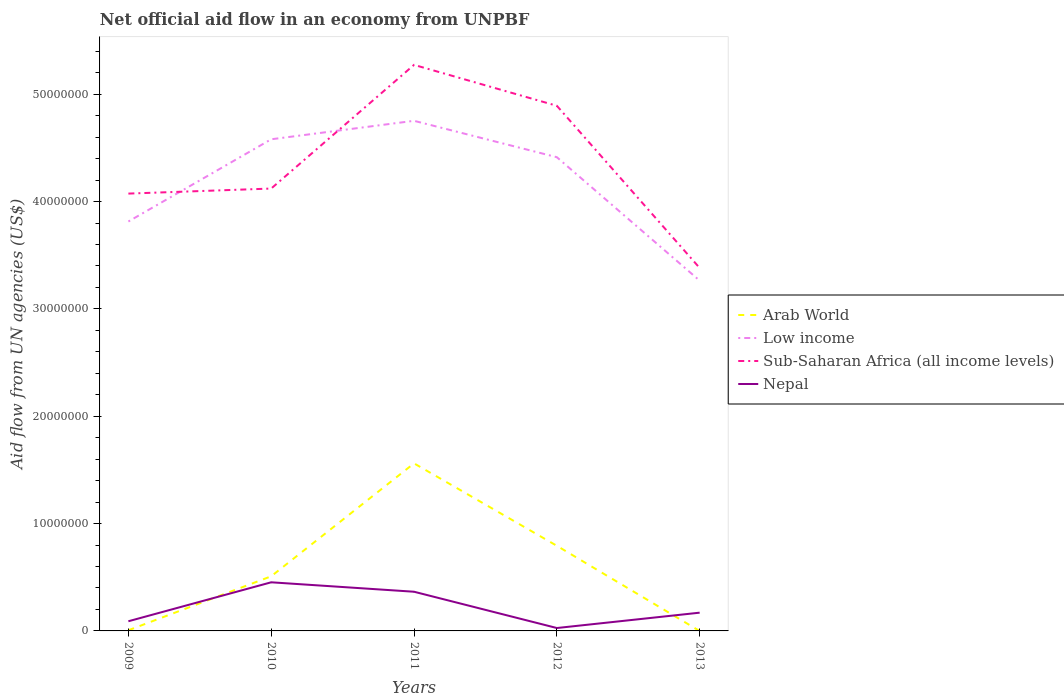How many different coloured lines are there?
Your answer should be very brief. 4. Does the line corresponding to Nepal intersect with the line corresponding to Arab World?
Give a very brief answer. Yes. Is the number of lines equal to the number of legend labels?
Give a very brief answer. No. Across all years, what is the maximum net official aid flow in Sub-Saharan Africa (all income levels)?
Offer a very short reply. 3.38e+07. What is the total net official aid flow in Nepal in the graph?
Provide a succinct answer. 3.38e+06. What is the difference between the highest and the second highest net official aid flow in Nepal?
Provide a succinct answer. 4.26e+06. Is the net official aid flow in Nepal strictly greater than the net official aid flow in Arab World over the years?
Keep it short and to the point. No. How many lines are there?
Provide a succinct answer. 4. What is the difference between two consecutive major ticks on the Y-axis?
Your answer should be compact. 1.00e+07. Does the graph contain any zero values?
Provide a short and direct response. Yes. Does the graph contain grids?
Offer a very short reply. No. Where does the legend appear in the graph?
Provide a short and direct response. Center right. How many legend labels are there?
Ensure brevity in your answer.  4. How are the legend labels stacked?
Offer a terse response. Vertical. What is the title of the graph?
Provide a succinct answer. Net official aid flow in an economy from UNPBF. Does "Malta" appear as one of the legend labels in the graph?
Your answer should be very brief. No. What is the label or title of the X-axis?
Offer a terse response. Years. What is the label or title of the Y-axis?
Your answer should be compact. Aid flow from UN agencies (US$). What is the Aid flow from UN agencies (US$) in Low income in 2009?
Provide a short and direct response. 3.81e+07. What is the Aid flow from UN agencies (US$) of Sub-Saharan Africa (all income levels) in 2009?
Offer a very short reply. 4.07e+07. What is the Aid flow from UN agencies (US$) in Arab World in 2010?
Your response must be concise. 5.09e+06. What is the Aid flow from UN agencies (US$) in Low income in 2010?
Offer a very short reply. 4.58e+07. What is the Aid flow from UN agencies (US$) of Sub-Saharan Africa (all income levels) in 2010?
Ensure brevity in your answer.  4.12e+07. What is the Aid flow from UN agencies (US$) in Nepal in 2010?
Offer a terse response. 4.53e+06. What is the Aid flow from UN agencies (US$) in Arab World in 2011?
Give a very brief answer. 1.56e+07. What is the Aid flow from UN agencies (US$) in Low income in 2011?
Give a very brief answer. 4.75e+07. What is the Aid flow from UN agencies (US$) of Sub-Saharan Africa (all income levels) in 2011?
Provide a short and direct response. 5.27e+07. What is the Aid flow from UN agencies (US$) in Nepal in 2011?
Your answer should be very brief. 3.65e+06. What is the Aid flow from UN agencies (US$) of Arab World in 2012?
Provide a short and direct response. 7.93e+06. What is the Aid flow from UN agencies (US$) of Low income in 2012?
Offer a terse response. 4.41e+07. What is the Aid flow from UN agencies (US$) of Sub-Saharan Africa (all income levels) in 2012?
Provide a succinct answer. 4.89e+07. What is the Aid flow from UN agencies (US$) in Nepal in 2012?
Give a very brief answer. 2.70e+05. What is the Aid flow from UN agencies (US$) in Arab World in 2013?
Your answer should be very brief. 0. What is the Aid flow from UN agencies (US$) in Low income in 2013?
Give a very brief answer. 3.26e+07. What is the Aid flow from UN agencies (US$) of Sub-Saharan Africa (all income levels) in 2013?
Your response must be concise. 3.38e+07. What is the Aid flow from UN agencies (US$) in Nepal in 2013?
Give a very brief answer. 1.70e+06. Across all years, what is the maximum Aid flow from UN agencies (US$) in Arab World?
Make the answer very short. 1.56e+07. Across all years, what is the maximum Aid flow from UN agencies (US$) of Low income?
Your response must be concise. 4.75e+07. Across all years, what is the maximum Aid flow from UN agencies (US$) in Sub-Saharan Africa (all income levels)?
Ensure brevity in your answer.  5.27e+07. Across all years, what is the maximum Aid flow from UN agencies (US$) of Nepal?
Make the answer very short. 4.53e+06. Across all years, what is the minimum Aid flow from UN agencies (US$) in Low income?
Give a very brief answer. 3.26e+07. Across all years, what is the minimum Aid flow from UN agencies (US$) in Sub-Saharan Africa (all income levels)?
Provide a short and direct response. 3.38e+07. Across all years, what is the minimum Aid flow from UN agencies (US$) in Nepal?
Offer a very short reply. 2.70e+05. What is the total Aid flow from UN agencies (US$) of Arab World in the graph?
Give a very brief answer. 2.87e+07. What is the total Aid flow from UN agencies (US$) in Low income in the graph?
Offer a terse response. 2.08e+08. What is the total Aid flow from UN agencies (US$) of Sub-Saharan Africa (all income levels) in the graph?
Provide a succinct answer. 2.17e+08. What is the total Aid flow from UN agencies (US$) in Nepal in the graph?
Provide a succinct answer. 1.10e+07. What is the difference between the Aid flow from UN agencies (US$) of Arab World in 2009 and that in 2010?
Your response must be concise. -5.03e+06. What is the difference between the Aid flow from UN agencies (US$) in Low income in 2009 and that in 2010?
Offer a terse response. -7.66e+06. What is the difference between the Aid flow from UN agencies (US$) in Sub-Saharan Africa (all income levels) in 2009 and that in 2010?
Ensure brevity in your answer.  -4.70e+05. What is the difference between the Aid flow from UN agencies (US$) in Nepal in 2009 and that in 2010?
Provide a succinct answer. -3.63e+06. What is the difference between the Aid flow from UN agencies (US$) of Arab World in 2009 and that in 2011?
Your response must be concise. -1.56e+07. What is the difference between the Aid flow from UN agencies (US$) of Low income in 2009 and that in 2011?
Keep it short and to the point. -9.38e+06. What is the difference between the Aid flow from UN agencies (US$) of Sub-Saharan Africa (all income levels) in 2009 and that in 2011?
Offer a terse response. -1.20e+07. What is the difference between the Aid flow from UN agencies (US$) of Nepal in 2009 and that in 2011?
Ensure brevity in your answer.  -2.75e+06. What is the difference between the Aid flow from UN agencies (US$) of Arab World in 2009 and that in 2012?
Keep it short and to the point. -7.87e+06. What is the difference between the Aid flow from UN agencies (US$) of Low income in 2009 and that in 2012?
Offer a terse response. -5.99e+06. What is the difference between the Aid flow from UN agencies (US$) of Sub-Saharan Africa (all income levels) in 2009 and that in 2012?
Ensure brevity in your answer.  -8.18e+06. What is the difference between the Aid flow from UN agencies (US$) in Nepal in 2009 and that in 2012?
Provide a succinct answer. 6.30e+05. What is the difference between the Aid flow from UN agencies (US$) in Low income in 2009 and that in 2013?
Provide a succinct answer. 5.51e+06. What is the difference between the Aid flow from UN agencies (US$) of Sub-Saharan Africa (all income levels) in 2009 and that in 2013?
Provide a short and direct response. 6.93e+06. What is the difference between the Aid flow from UN agencies (US$) in Nepal in 2009 and that in 2013?
Your response must be concise. -8.00e+05. What is the difference between the Aid flow from UN agencies (US$) of Arab World in 2010 and that in 2011?
Keep it short and to the point. -1.05e+07. What is the difference between the Aid flow from UN agencies (US$) in Low income in 2010 and that in 2011?
Your response must be concise. -1.72e+06. What is the difference between the Aid flow from UN agencies (US$) in Sub-Saharan Africa (all income levels) in 2010 and that in 2011?
Your answer should be compact. -1.15e+07. What is the difference between the Aid flow from UN agencies (US$) of Nepal in 2010 and that in 2011?
Offer a terse response. 8.80e+05. What is the difference between the Aid flow from UN agencies (US$) of Arab World in 2010 and that in 2012?
Your response must be concise. -2.84e+06. What is the difference between the Aid flow from UN agencies (US$) in Low income in 2010 and that in 2012?
Make the answer very short. 1.67e+06. What is the difference between the Aid flow from UN agencies (US$) in Sub-Saharan Africa (all income levels) in 2010 and that in 2012?
Offer a terse response. -7.71e+06. What is the difference between the Aid flow from UN agencies (US$) of Nepal in 2010 and that in 2012?
Provide a succinct answer. 4.26e+06. What is the difference between the Aid flow from UN agencies (US$) of Low income in 2010 and that in 2013?
Give a very brief answer. 1.32e+07. What is the difference between the Aid flow from UN agencies (US$) in Sub-Saharan Africa (all income levels) in 2010 and that in 2013?
Make the answer very short. 7.40e+06. What is the difference between the Aid flow from UN agencies (US$) in Nepal in 2010 and that in 2013?
Give a very brief answer. 2.83e+06. What is the difference between the Aid flow from UN agencies (US$) in Arab World in 2011 and that in 2012?
Ensure brevity in your answer.  7.68e+06. What is the difference between the Aid flow from UN agencies (US$) of Low income in 2011 and that in 2012?
Keep it short and to the point. 3.39e+06. What is the difference between the Aid flow from UN agencies (US$) of Sub-Saharan Africa (all income levels) in 2011 and that in 2012?
Make the answer very short. 3.81e+06. What is the difference between the Aid flow from UN agencies (US$) of Nepal in 2011 and that in 2012?
Provide a succinct answer. 3.38e+06. What is the difference between the Aid flow from UN agencies (US$) of Low income in 2011 and that in 2013?
Your response must be concise. 1.49e+07. What is the difference between the Aid flow from UN agencies (US$) in Sub-Saharan Africa (all income levels) in 2011 and that in 2013?
Your answer should be compact. 1.89e+07. What is the difference between the Aid flow from UN agencies (US$) of Nepal in 2011 and that in 2013?
Ensure brevity in your answer.  1.95e+06. What is the difference between the Aid flow from UN agencies (US$) in Low income in 2012 and that in 2013?
Keep it short and to the point. 1.15e+07. What is the difference between the Aid flow from UN agencies (US$) of Sub-Saharan Africa (all income levels) in 2012 and that in 2013?
Your answer should be very brief. 1.51e+07. What is the difference between the Aid flow from UN agencies (US$) in Nepal in 2012 and that in 2013?
Offer a very short reply. -1.43e+06. What is the difference between the Aid flow from UN agencies (US$) in Arab World in 2009 and the Aid flow from UN agencies (US$) in Low income in 2010?
Give a very brief answer. -4.57e+07. What is the difference between the Aid flow from UN agencies (US$) in Arab World in 2009 and the Aid flow from UN agencies (US$) in Sub-Saharan Africa (all income levels) in 2010?
Provide a succinct answer. -4.12e+07. What is the difference between the Aid flow from UN agencies (US$) of Arab World in 2009 and the Aid flow from UN agencies (US$) of Nepal in 2010?
Ensure brevity in your answer.  -4.47e+06. What is the difference between the Aid flow from UN agencies (US$) in Low income in 2009 and the Aid flow from UN agencies (US$) in Sub-Saharan Africa (all income levels) in 2010?
Provide a short and direct response. -3.07e+06. What is the difference between the Aid flow from UN agencies (US$) in Low income in 2009 and the Aid flow from UN agencies (US$) in Nepal in 2010?
Provide a succinct answer. 3.36e+07. What is the difference between the Aid flow from UN agencies (US$) in Sub-Saharan Africa (all income levels) in 2009 and the Aid flow from UN agencies (US$) in Nepal in 2010?
Give a very brief answer. 3.62e+07. What is the difference between the Aid flow from UN agencies (US$) in Arab World in 2009 and the Aid flow from UN agencies (US$) in Low income in 2011?
Offer a very short reply. -4.75e+07. What is the difference between the Aid flow from UN agencies (US$) in Arab World in 2009 and the Aid flow from UN agencies (US$) in Sub-Saharan Africa (all income levels) in 2011?
Keep it short and to the point. -5.27e+07. What is the difference between the Aid flow from UN agencies (US$) of Arab World in 2009 and the Aid flow from UN agencies (US$) of Nepal in 2011?
Your response must be concise. -3.59e+06. What is the difference between the Aid flow from UN agencies (US$) of Low income in 2009 and the Aid flow from UN agencies (US$) of Sub-Saharan Africa (all income levels) in 2011?
Ensure brevity in your answer.  -1.46e+07. What is the difference between the Aid flow from UN agencies (US$) of Low income in 2009 and the Aid flow from UN agencies (US$) of Nepal in 2011?
Your answer should be very brief. 3.45e+07. What is the difference between the Aid flow from UN agencies (US$) of Sub-Saharan Africa (all income levels) in 2009 and the Aid flow from UN agencies (US$) of Nepal in 2011?
Keep it short and to the point. 3.71e+07. What is the difference between the Aid flow from UN agencies (US$) in Arab World in 2009 and the Aid flow from UN agencies (US$) in Low income in 2012?
Your answer should be very brief. -4.41e+07. What is the difference between the Aid flow from UN agencies (US$) of Arab World in 2009 and the Aid flow from UN agencies (US$) of Sub-Saharan Africa (all income levels) in 2012?
Your answer should be very brief. -4.89e+07. What is the difference between the Aid flow from UN agencies (US$) in Arab World in 2009 and the Aid flow from UN agencies (US$) in Nepal in 2012?
Give a very brief answer. -2.10e+05. What is the difference between the Aid flow from UN agencies (US$) of Low income in 2009 and the Aid flow from UN agencies (US$) of Sub-Saharan Africa (all income levels) in 2012?
Provide a succinct answer. -1.08e+07. What is the difference between the Aid flow from UN agencies (US$) in Low income in 2009 and the Aid flow from UN agencies (US$) in Nepal in 2012?
Provide a short and direct response. 3.79e+07. What is the difference between the Aid flow from UN agencies (US$) of Sub-Saharan Africa (all income levels) in 2009 and the Aid flow from UN agencies (US$) of Nepal in 2012?
Your response must be concise. 4.05e+07. What is the difference between the Aid flow from UN agencies (US$) of Arab World in 2009 and the Aid flow from UN agencies (US$) of Low income in 2013?
Keep it short and to the point. -3.26e+07. What is the difference between the Aid flow from UN agencies (US$) of Arab World in 2009 and the Aid flow from UN agencies (US$) of Sub-Saharan Africa (all income levels) in 2013?
Offer a very short reply. -3.38e+07. What is the difference between the Aid flow from UN agencies (US$) of Arab World in 2009 and the Aid flow from UN agencies (US$) of Nepal in 2013?
Make the answer very short. -1.64e+06. What is the difference between the Aid flow from UN agencies (US$) in Low income in 2009 and the Aid flow from UN agencies (US$) in Sub-Saharan Africa (all income levels) in 2013?
Offer a terse response. 4.33e+06. What is the difference between the Aid flow from UN agencies (US$) of Low income in 2009 and the Aid flow from UN agencies (US$) of Nepal in 2013?
Your answer should be compact. 3.64e+07. What is the difference between the Aid flow from UN agencies (US$) of Sub-Saharan Africa (all income levels) in 2009 and the Aid flow from UN agencies (US$) of Nepal in 2013?
Your answer should be compact. 3.90e+07. What is the difference between the Aid flow from UN agencies (US$) in Arab World in 2010 and the Aid flow from UN agencies (US$) in Low income in 2011?
Ensure brevity in your answer.  -4.24e+07. What is the difference between the Aid flow from UN agencies (US$) in Arab World in 2010 and the Aid flow from UN agencies (US$) in Sub-Saharan Africa (all income levels) in 2011?
Offer a terse response. -4.76e+07. What is the difference between the Aid flow from UN agencies (US$) of Arab World in 2010 and the Aid flow from UN agencies (US$) of Nepal in 2011?
Provide a succinct answer. 1.44e+06. What is the difference between the Aid flow from UN agencies (US$) in Low income in 2010 and the Aid flow from UN agencies (US$) in Sub-Saharan Africa (all income levels) in 2011?
Offer a very short reply. -6.93e+06. What is the difference between the Aid flow from UN agencies (US$) in Low income in 2010 and the Aid flow from UN agencies (US$) in Nepal in 2011?
Ensure brevity in your answer.  4.22e+07. What is the difference between the Aid flow from UN agencies (US$) of Sub-Saharan Africa (all income levels) in 2010 and the Aid flow from UN agencies (US$) of Nepal in 2011?
Ensure brevity in your answer.  3.76e+07. What is the difference between the Aid flow from UN agencies (US$) of Arab World in 2010 and the Aid flow from UN agencies (US$) of Low income in 2012?
Ensure brevity in your answer.  -3.90e+07. What is the difference between the Aid flow from UN agencies (US$) of Arab World in 2010 and the Aid flow from UN agencies (US$) of Sub-Saharan Africa (all income levels) in 2012?
Provide a succinct answer. -4.38e+07. What is the difference between the Aid flow from UN agencies (US$) in Arab World in 2010 and the Aid flow from UN agencies (US$) in Nepal in 2012?
Keep it short and to the point. 4.82e+06. What is the difference between the Aid flow from UN agencies (US$) in Low income in 2010 and the Aid flow from UN agencies (US$) in Sub-Saharan Africa (all income levels) in 2012?
Your response must be concise. -3.12e+06. What is the difference between the Aid flow from UN agencies (US$) of Low income in 2010 and the Aid flow from UN agencies (US$) of Nepal in 2012?
Offer a very short reply. 4.55e+07. What is the difference between the Aid flow from UN agencies (US$) in Sub-Saharan Africa (all income levels) in 2010 and the Aid flow from UN agencies (US$) in Nepal in 2012?
Ensure brevity in your answer.  4.09e+07. What is the difference between the Aid flow from UN agencies (US$) in Arab World in 2010 and the Aid flow from UN agencies (US$) in Low income in 2013?
Your answer should be compact. -2.75e+07. What is the difference between the Aid flow from UN agencies (US$) of Arab World in 2010 and the Aid flow from UN agencies (US$) of Sub-Saharan Africa (all income levels) in 2013?
Make the answer very short. -2.87e+07. What is the difference between the Aid flow from UN agencies (US$) in Arab World in 2010 and the Aid flow from UN agencies (US$) in Nepal in 2013?
Offer a very short reply. 3.39e+06. What is the difference between the Aid flow from UN agencies (US$) of Low income in 2010 and the Aid flow from UN agencies (US$) of Sub-Saharan Africa (all income levels) in 2013?
Make the answer very short. 1.20e+07. What is the difference between the Aid flow from UN agencies (US$) of Low income in 2010 and the Aid flow from UN agencies (US$) of Nepal in 2013?
Your response must be concise. 4.41e+07. What is the difference between the Aid flow from UN agencies (US$) of Sub-Saharan Africa (all income levels) in 2010 and the Aid flow from UN agencies (US$) of Nepal in 2013?
Offer a terse response. 3.95e+07. What is the difference between the Aid flow from UN agencies (US$) of Arab World in 2011 and the Aid flow from UN agencies (US$) of Low income in 2012?
Keep it short and to the point. -2.85e+07. What is the difference between the Aid flow from UN agencies (US$) of Arab World in 2011 and the Aid flow from UN agencies (US$) of Sub-Saharan Africa (all income levels) in 2012?
Your response must be concise. -3.33e+07. What is the difference between the Aid flow from UN agencies (US$) in Arab World in 2011 and the Aid flow from UN agencies (US$) in Nepal in 2012?
Provide a short and direct response. 1.53e+07. What is the difference between the Aid flow from UN agencies (US$) of Low income in 2011 and the Aid flow from UN agencies (US$) of Sub-Saharan Africa (all income levels) in 2012?
Keep it short and to the point. -1.40e+06. What is the difference between the Aid flow from UN agencies (US$) in Low income in 2011 and the Aid flow from UN agencies (US$) in Nepal in 2012?
Give a very brief answer. 4.72e+07. What is the difference between the Aid flow from UN agencies (US$) of Sub-Saharan Africa (all income levels) in 2011 and the Aid flow from UN agencies (US$) of Nepal in 2012?
Provide a succinct answer. 5.25e+07. What is the difference between the Aid flow from UN agencies (US$) of Arab World in 2011 and the Aid flow from UN agencies (US$) of Low income in 2013?
Provide a short and direct response. -1.70e+07. What is the difference between the Aid flow from UN agencies (US$) in Arab World in 2011 and the Aid flow from UN agencies (US$) in Sub-Saharan Africa (all income levels) in 2013?
Ensure brevity in your answer.  -1.82e+07. What is the difference between the Aid flow from UN agencies (US$) of Arab World in 2011 and the Aid flow from UN agencies (US$) of Nepal in 2013?
Provide a succinct answer. 1.39e+07. What is the difference between the Aid flow from UN agencies (US$) of Low income in 2011 and the Aid flow from UN agencies (US$) of Sub-Saharan Africa (all income levels) in 2013?
Keep it short and to the point. 1.37e+07. What is the difference between the Aid flow from UN agencies (US$) in Low income in 2011 and the Aid flow from UN agencies (US$) in Nepal in 2013?
Provide a short and direct response. 4.58e+07. What is the difference between the Aid flow from UN agencies (US$) of Sub-Saharan Africa (all income levels) in 2011 and the Aid flow from UN agencies (US$) of Nepal in 2013?
Offer a very short reply. 5.10e+07. What is the difference between the Aid flow from UN agencies (US$) of Arab World in 2012 and the Aid flow from UN agencies (US$) of Low income in 2013?
Give a very brief answer. -2.47e+07. What is the difference between the Aid flow from UN agencies (US$) of Arab World in 2012 and the Aid flow from UN agencies (US$) of Sub-Saharan Africa (all income levels) in 2013?
Provide a succinct answer. -2.59e+07. What is the difference between the Aid flow from UN agencies (US$) in Arab World in 2012 and the Aid flow from UN agencies (US$) in Nepal in 2013?
Your response must be concise. 6.23e+06. What is the difference between the Aid flow from UN agencies (US$) of Low income in 2012 and the Aid flow from UN agencies (US$) of Sub-Saharan Africa (all income levels) in 2013?
Offer a terse response. 1.03e+07. What is the difference between the Aid flow from UN agencies (US$) in Low income in 2012 and the Aid flow from UN agencies (US$) in Nepal in 2013?
Your answer should be compact. 4.24e+07. What is the difference between the Aid flow from UN agencies (US$) of Sub-Saharan Africa (all income levels) in 2012 and the Aid flow from UN agencies (US$) of Nepal in 2013?
Ensure brevity in your answer.  4.72e+07. What is the average Aid flow from UN agencies (US$) in Arab World per year?
Ensure brevity in your answer.  5.74e+06. What is the average Aid flow from UN agencies (US$) of Low income per year?
Your answer should be compact. 4.16e+07. What is the average Aid flow from UN agencies (US$) in Sub-Saharan Africa (all income levels) per year?
Your answer should be very brief. 4.35e+07. What is the average Aid flow from UN agencies (US$) of Nepal per year?
Provide a succinct answer. 2.21e+06. In the year 2009, what is the difference between the Aid flow from UN agencies (US$) in Arab World and Aid flow from UN agencies (US$) in Low income?
Keep it short and to the point. -3.81e+07. In the year 2009, what is the difference between the Aid flow from UN agencies (US$) of Arab World and Aid flow from UN agencies (US$) of Sub-Saharan Africa (all income levels)?
Give a very brief answer. -4.07e+07. In the year 2009, what is the difference between the Aid flow from UN agencies (US$) in Arab World and Aid flow from UN agencies (US$) in Nepal?
Your answer should be very brief. -8.40e+05. In the year 2009, what is the difference between the Aid flow from UN agencies (US$) in Low income and Aid flow from UN agencies (US$) in Sub-Saharan Africa (all income levels)?
Provide a succinct answer. -2.60e+06. In the year 2009, what is the difference between the Aid flow from UN agencies (US$) in Low income and Aid flow from UN agencies (US$) in Nepal?
Your answer should be very brief. 3.72e+07. In the year 2009, what is the difference between the Aid flow from UN agencies (US$) of Sub-Saharan Africa (all income levels) and Aid flow from UN agencies (US$) of Nepal?
Keep it short and to the point. 3.98e+07. In the year 2010, what is the difference between the Aid flow from UN agencies (US$) in Arab World and Aid flow from UN agencies (US$) in Low income?
Ensure brevity in your answer.  -4.07e+07. In the year 2010, what is the difference between the Aid flow from UN agencies (US$) of Arab World and Aid flow from UN agencies (US$) of Sub-Saharan Africa (all income levels)?
Provide a succinct answer. -3.61e+07. In the year 2010, what is the difference between the Aid flow from UN agencies (US$) of Arab World and Aid flow from UN agencies (US$) of Nepal?
Keep it short and to the point. 5.60e+05. In the year 2010, what is the difference between the Aid flow from UN agencies (US$) of Low income and Aid flow from UN agencies (US$) of Sub-Saharan Africa (all income levels)?
Give a very brief answer. 4.59e+06. In the year 2010, what is the difference between the Aid flow from UN agencies (US$) of Low income and Aid flow from UN agencies (US$) of Nepal?
Your answer should be very brief. 4.13e+07. In the year 2010, what is the difference between the Aid flow from UN agencies (US$) of Sub-Saharan Africa (all income levels) and Aid flow from UN agencies (US$) of Nepal?
Ensure brevity in your answer.  3.67e+07. In the year 2011, what is the difference between the Aid flow from UN agencies (US$) in Arab World and Aid flow from UN agencies (US$) in Low income?
Offer a terse response. -3.19e+07. In the year 2011, what is the difference between the Aid flow from UN agencies (US$) in Arab World and Aid flow from UN agencies (US$) in Sub-Saharan Africa (all income levels)?
Your response must be concise. -3.71e+07. In the year 2011, what is the difference between the Aid flow from UN agencies (US$) in Arab World and Aid flow from UN agencies (US$) in Nepal?
Keep it short and to the point. 1.20e+07. In the year 2011, what is the difference between the Aid flow from UN agencies (US$) in Low income and Aid flow from UN agencies (US$) in Sub-Saharan Africa (all income levels)?
Keep it short and to the point. -5.21e+06. In the year 2011, what is the difference between the Aid flow from UN agencies (US$) of Low income and Aid flow from UN agencies (US$) of Nepal?
Your response must be concise. 4.39e+07. In the year 2011, what is the difference between the Aid flow from UN agencies (US$) in Sub-Saharan Africa (all income levels) and Aid flow from UN agencies (US$) in Nepal?
Offer a terse response. 4.91e+07. In the year 2012, what is the difference between the Aid flow from UN agencies (US$) in Arab World and Aid flow from UN agencies (US$) in Low income?
Provide a succinct answer. -3.62e+07. In the year 2012, what is the difference between the Aid flow from UN agencies (US$) of Arab World and Aid flow from UN agencies (US$) of Sub-Saharan Africa (all income levels)?
Ensure brevity in your answer.  -4.10e+07. In the year 2012, what is the difference between the Aid flow from UN agencies (US$) of Arab World and Aid flow from UN agencies (US$) of Nepal?
Provide a succinct answer. 7.66e+06. In the year 2012, what is the difference between the Aid flow from UN agencies (US$) in Low income and Aid flow from UN agencies (US$) in Sub-Saharan Africa (all income levels)?
Your answer should be compact. -4.79e+06. In the year 2012, what is the difference between the Aid flow from UN agencies (US$) of Low income and Aid flow from UN agencies (US$) of Nepal?
Ensure brevity in your answer.  4.39e+07. In the year 2012, what is the difference between the Aid flow from UN agencies (US$) in Sub-Saharan Africa (all income levels) and Aid flow from UN agencies (US$) in Nepal?
Ensure brevity in your answer.  4.86e+07. In the year 2013, what is the difference between the Aid flow from UN agencies (US$) of Low income and Aid flow from UN agencies (US$) of Sub-Saharan Africa (all income levels)?
Ensure brevity in your answer.  -1.18e+06. In the year 2013, what is the difference between the Aid flow from UN agencies (US$) in Low income and Aid flow from UN agencies (US$) in Nepal?
Make the answer very short. 3.09e+07. In the year 2013, what is the difference between the Aid flow from UN agencies (US$) in Sub-Saharan Africa (all income levels) and Aid flow from UN agencies (US$) in Nepal?
Your answer should be very brief. 3.21e+07. What is the ratio of the Aid flow from UN agencies (US$) in Arab World in 2009 to that in 2010?
Your response must be concise. 0.01. What is the ratio of the Aid flow from UN agencies (US$) in Low income in 2009 to that in 2010?
Give a very brief answer. 0.83. What is the ratio of the Aid flow from UN agencies (US$) of Sub-Saharan Africa (all income levels) in 2009 to that in 2010?
Ensure brevity in your answer.  0.99. What is the ratio of the Aid flow from UN agencies (US$) of Nepal in 2009 to that in 2010?
Your response must be concise. 0.2. What is the ratio of the Aid flow from UN agencies (US$) in Arab World in 2009 to that in 2011?
Ensure brevity in your answer.  0. What is the ratio of the Aid flow from UN agencies (US$) of Low income in 2009 to that in 2011?
Ensure brevity in your answer.  0.8. What is the ratio of the Aid flow from UN agencies (US$) of Sub-Saharan Africa (all income levels) in 2009 to that in 2011?
Give a very brief answer. 0.77. What is the ratio of the Aid flow from UN agencies (US$) in Nepal in 2009 to that in 2011?
Your answer should be compact. 0.25. What is the ratio of the Aid flow from UN agencies (US$) in Arab World in 2009 to that in 2012?
Offer a terse response. 0.01. What is the ratio of the Aid flow from UN agencies (US$) in Low income in 2009 to that in 2012?
Your answer should be very brief. 0.86. What is the ratio of the Aid flow from UN agencies (US$) in Sub-Saharan Africa (all income levels) in 2009 to that in 2012?
Provide a succinct answer. 0.83. What is the ratio of the Aid flow from UN agencies (US$) of Low income in 2009 to that in 2013?
Your answer should be compact. 1.17. What is the ratio of the Aid flow from UN agencies (US$) of Sub-Saharan Africa (all income levels) in 2009 to that in 2013?
Give a very brief answer. 1.21. What is the ratio of the Aid flow from UN agencies (US$) of Nepal in 2009 to that in 2013?
Keep it short and to the point. 0.53. What is the ratio of the Aid flow from UN agencies (US$) in Arab World in 2010 to that in 2011?
Give a very brief answer. 0.33. What is the ratio of the Aid flow from UN agencies (US$) in Low income in 2010 to that in 2011?
Your response must be concise. 0.96. What is the ratio of the Aid flow from UN agencies (US$) of Sub-Saharan Africa (all income levels) in 2010 to that in 2011?
Provide a succinct answer. 0.78. What is the ratio of the Aid flow from UN agencies (US$) of Nepal in 2010 to that in 2011?
Give a very brief answer. 1.24. What is the ratio of the Aid flow from UN agencies (US$) in Arab World in 2010 to that in 2012?
Provide a succinct answer. 0.64. What is the ratio of the Aid flow from UN agencies (US$) in Low income in 2010 to that in 2012?
Offer a very short reply. 1.04. What is the ratio of the Aid flow from UN agencies (US$) of Sub-Saharan Africa (all income levels) in 2010 to that in 2012?
Your response must be concise. 0.84. What is the ratio of the Aid flow from UN agencies (US$) of Nepal in 2010 to that in 2012?
Offer a very short reply. 16.78. What is the ratio of the Aid flow from UN agencies (US$) of Low income in 2010 to that in 2013?
Give a very brief answer. 1.4. What is the ratio of the Aid flow from UN agencies (US$) in Sub-Saharan Africa (all income levels) in 2010 to that in 2013?
Make the answer very short. 1.22. What is the ratio of the Aid flow from UN agencies (US$) of Nepal in 2010 to that in 2013?
Provide a short and direct response. 2.66. What is the ratio of the Aid flow from UN agencies (US$) of Arab World in 2011 to that in 2012?
Make the answer very short. 1.97. What is the ratio of the Aid flow from UN agencies (US$) of Low income in 2011 to that in 2012?
Offer a very short reply. 1.08. What is the ratio of the Aid flow from UN agencies (US$) of Sub-Saharan Africa (all income levels) in 2011 to that in 2012?
Offer a terse response. 1.08. What is the ratio of the Aid flow from UN agencies (US$) in Nepal in 2011 to that in 2012?
Your response must be concise. 13.52. What is the ratio of the Aid flow from UN agencies (US$) of Low income in 2011 to that in 2013?
Provide a succinct answer. 1.46. What is the ratio of the Aid flow from UN agencies (US$) in Sub-Saharan Africa (all income levels) in 2011 to that in 2013?
Ensure brevity in your answer.  1.56. What is the ratio of the Aid flow from UN agencies (US$) in Nepal in 2011 to that in 2013?
Ensure brevity in your answer.  2.15. What is the ratio of the Aid flow from UN agencies (US$) in Low income in 2012 to that in 2013?
Make the answer very short. 1.35. What is the ratio of the Aid flow from UN agencies (US$) of Sub-Saharan Africa (all income levels) in 2012 to that in 2013?
Provide a short and direct response. 1.45. What is the ratio of the Aid flow from UN agencies (US$) of Nepal in 2012 to that in 2013?
Ensure brevity in your answer.  0.16. What is the difference between the highest and the second highest Aid flow from UN agencies (US$) in Arab World?
Give a very brief answer. 7.68e+06. What is the difference between the highest and the second highest Aid flow from UN agencies (US$) of Low income?
Your answer should be compact. 1.72e+06. What is the difference between the highest and the second highest Aid flow from UN agencies (US$) in Sub-Saharan Africa (all income levels)?
Make the answer very short. 3.81e+06. What is the difference between the highest and the second highest Aid flow from UN agencies (US$) in Nepal?
Your answer should be very brief. 8.80e+05. What is the difference between the highest and the lowest Aid flow from UN agencies (US$) of Arab World?
Offer a very short reply. 1.56e+07. What is the difference between the highest and the lowest Aid flow from UN agencies (US$) of Low income?
Provide a succinct answer. 1.49e+07. What is the difference between the highest and the lowest Aid flow from UN agencies (US$) in Sub-Saharan Africa (all income levels)?
Provide a succinct answer. 1.89e+07. What is the difference between the highest and the lowest Aid flow from UN agencies (US$) of Nepal?
Provide a short and direct response. 4.26e+06. 